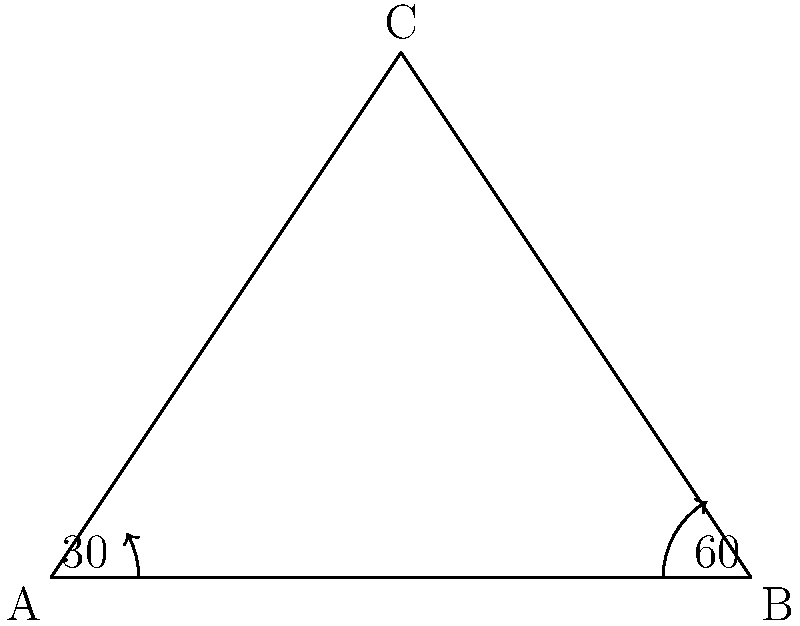In a pivotal scene of your filmmaker's mythological epic, three legendary creatures form a triangular formation. The angle at the position of the first creature is 30°, and the angle at the position of the second creature is 60°. What is the measure of the angle at the position of the third creature? To solve this problem, we can use the fundamental property of triangles that states the sum of all interior angles in a triangle is always 180°. Let's approach this step-by-step:

1. We know that in any triangle, $\angle A + \angle B + \angle C = 180°$

2. We are given:
   $\angle A = 30°$
   $\angle B = 60°$

3. Let $\angle C$ be the unknown angle we're looking for.

4. Substituting the known values into the equation:
   $30° + 60° + \angle C = 180°$

5. Simplifying:
   $90° + \angle C = 180°$

6. Subtracting 90° from both sides:
   $\angle C = 180° - 90° = 90°$

Therefore, the angle at the position of the third creature is 90°.
Answer: $90°$ 